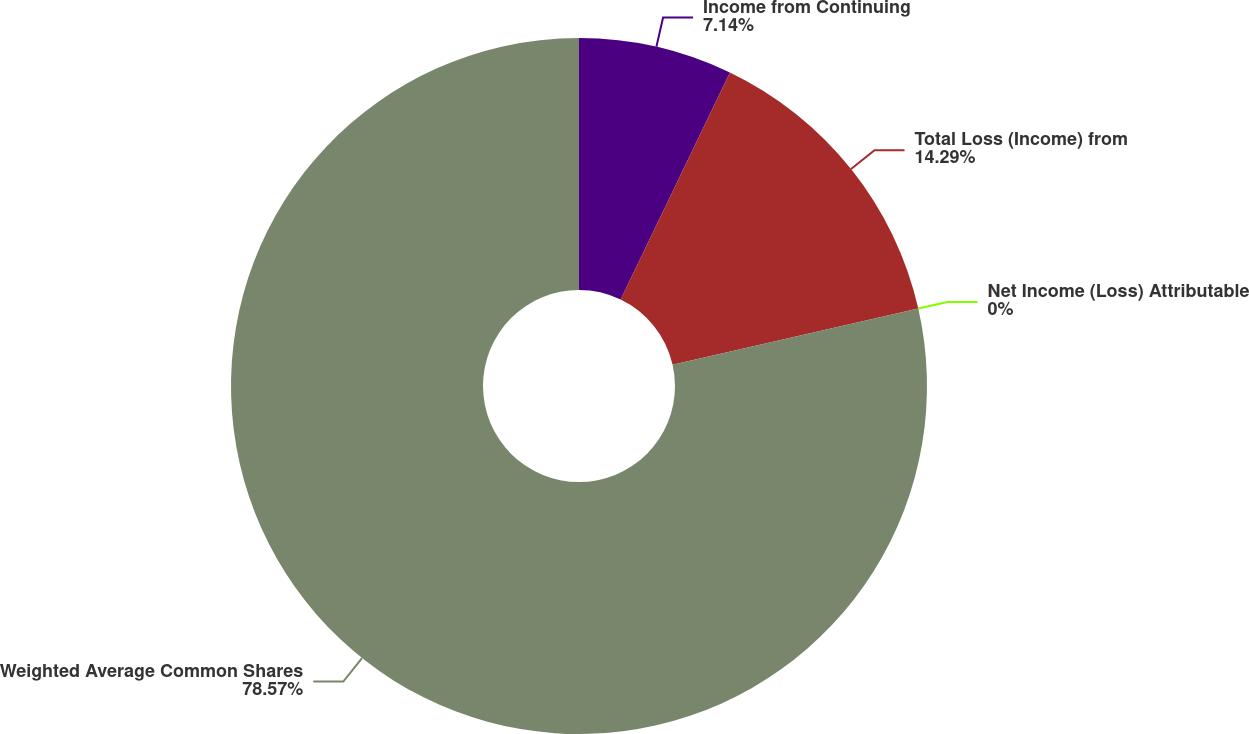Convert chart to OTSL. <chart><loc_0><loc_0><loc_500><loc_500><pie_chart><fcel>Income from Continuing<fcel>Total Loss (Income) from<fcel>Net Income (Loss) Attributable<fcel>Weighted Average Common Shares<nl><fcel>7.14%<fcel>14.29%<fcel>0.0%<fcel>78.57%<nl></chart> 